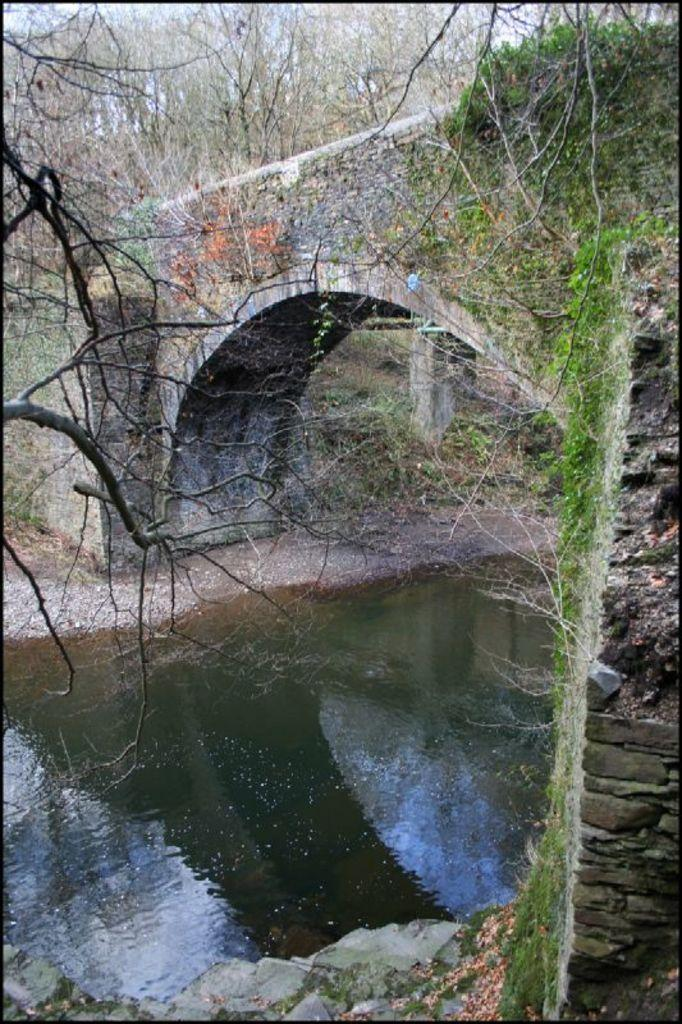What type of natural elements can be seen in the image? There are trees and water in the image. What man-made structure is present in the image? There is a bridge in the image. What is the color of the sky in the image? The sky appears to be white in color. What type of credit card is visible in the image? There is no credit card present in the image. What color is the orange in the image? There is no orange present in the image. 